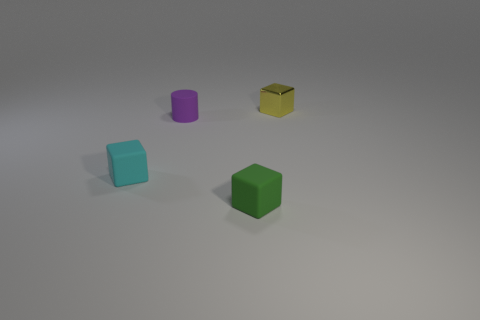Does the small cylinder have the same color as the matte thing that is on the right side of the purple object?
Offer a terse response. No. Is the number of big cubes less than the number of tiny yellow cubes?
Provide a short and direct response. Yes. Are there more small blocks on the right side of the tiny cyan cube than tiny things that are behind the yellow object?
Provide a short and direct response. Yes. Is the cyan object made of the same material as the tiny yellow cube?
Provide a succinct answer. No. There is a small matte block that is left of the tiny purple matte cylinder; how many tiny green rubber objects are behind it?
Your answer should be compact. 0. What number of objects are either small metallic objects or small objects in front of the small yellow metallic object?
Give a very brief answer. 4. There is a tiny green matte thing that is to the right of the purple rubber cylinder; is it the same shape as the matte thing that is behind the small cyan rubber thing?
Offer a terse response. No. What shape is the cyan thing that is made of the same material as the small green block?
Your response must be concise. Cube. The object that is both behind the tiny cyan thing and on the right side of the rubber cylinder is made of what material?
Give a very brief answer. Metal. What number of metal objects are the same shape as the cyan matte thing?
Ensure brevity in your answer.  1. 